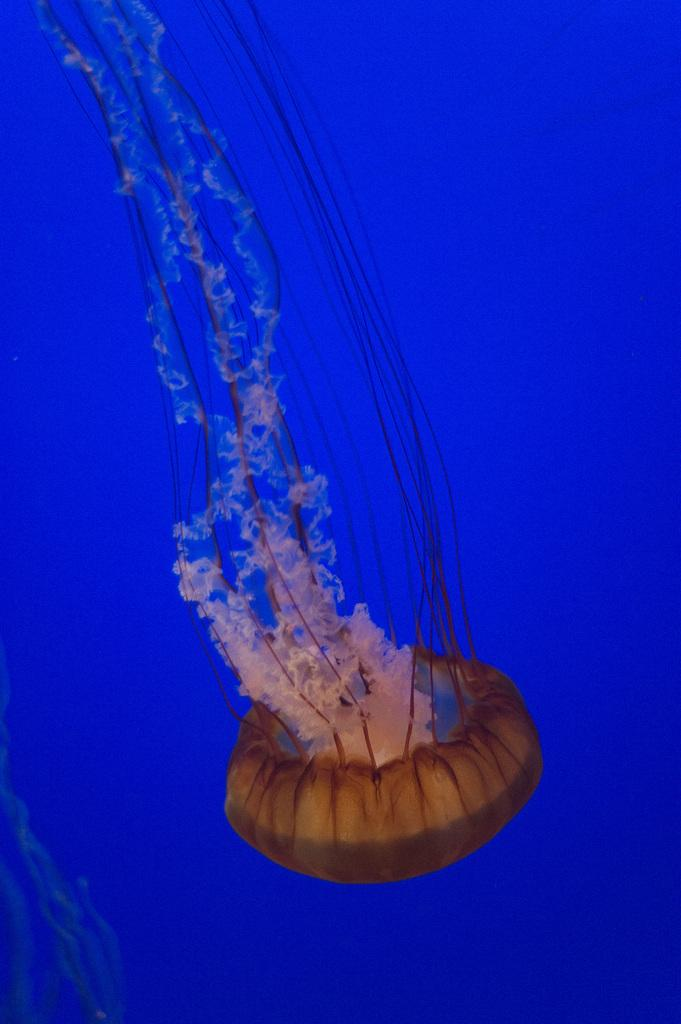What type of animal is in the image? There is a Jellyfish in the image. Where is the Jellyfish located? The Jellyfish is in the water. Who is the representative of the Jellyfish in the image? There is no representative present in the image, as it features a Jellyfish in the water. What is the grandmother doing in the image? There is no grandmother present in the image; it features a Jellyfish in the water. 